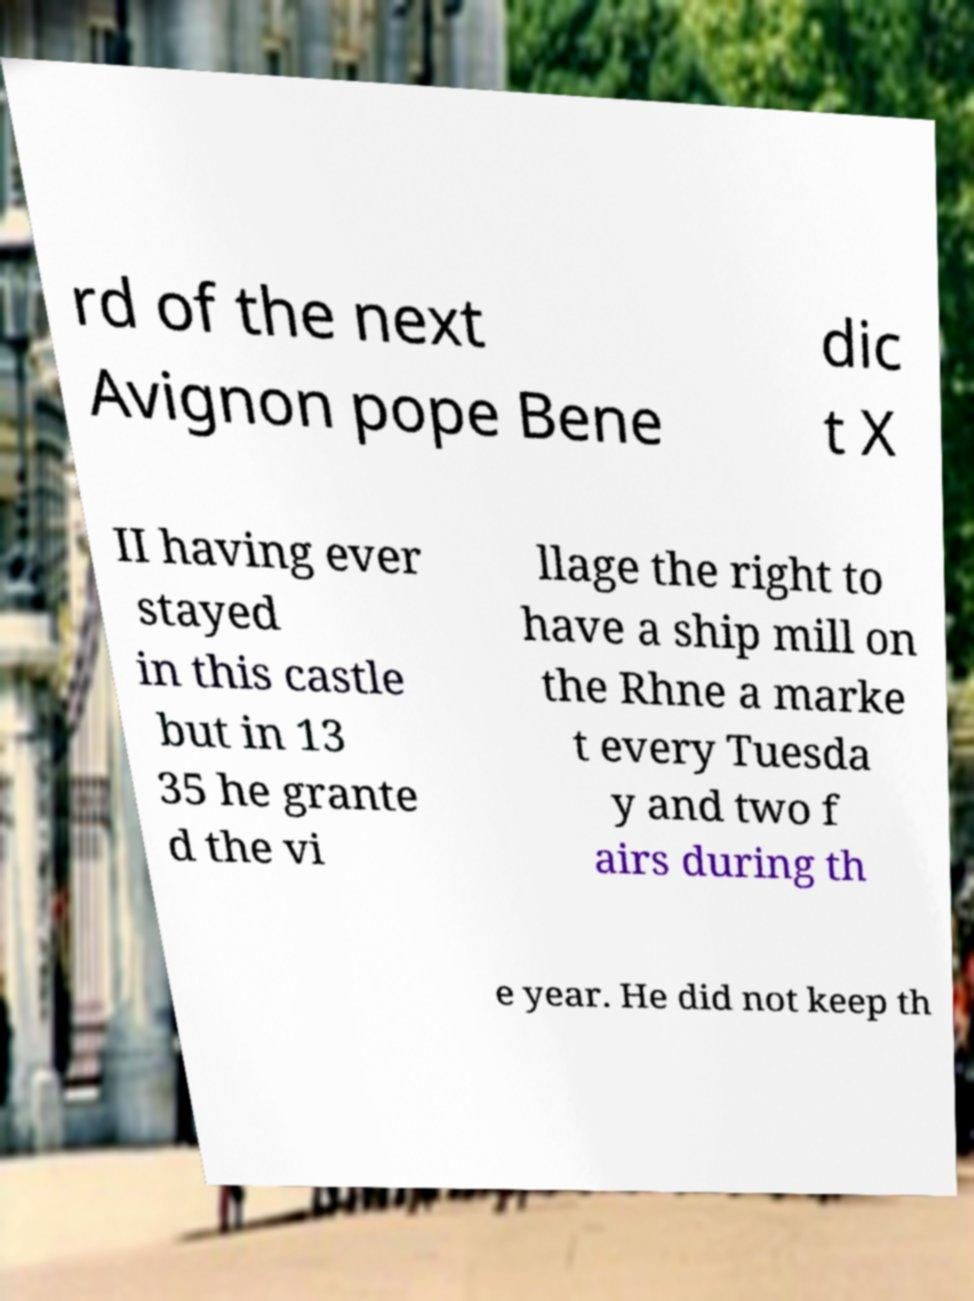I need the written content from this picture converted into text. Can you do that? rd of the next Avignon pope Bene dic t X II having ever stayed in this castle but in 13 35 he grante d the vi llage the right to have a ship mill on the Rhne a marke t every Tuesda y and two f airs during th e year. He did not keep th 